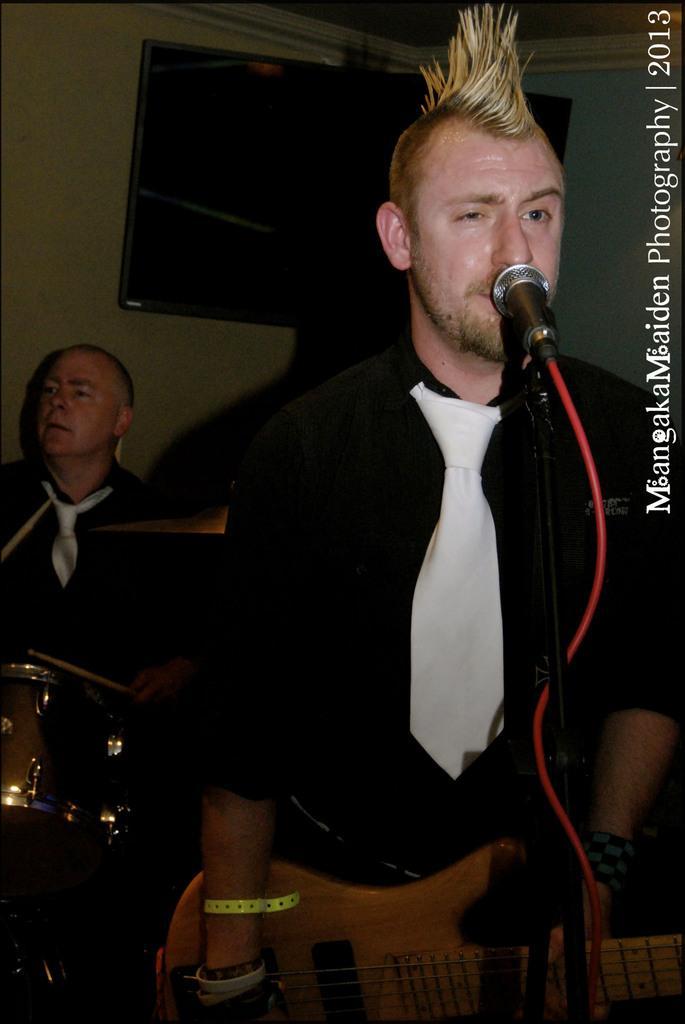Could you give a brief overview of what you see in this image? On the background we can see a wall and a television. We can see a man standing in front of a mike and playing guitar. Behind to this man we can see other man holding drum sticks in his hands and playing. 